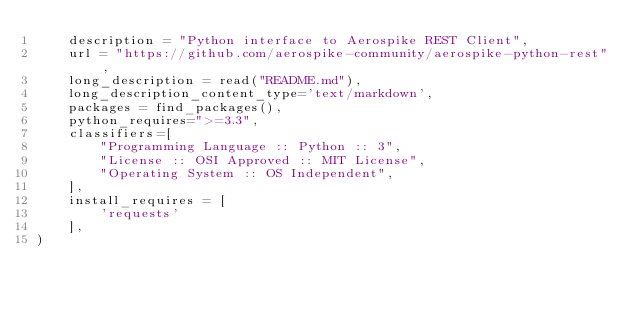Convert code to text. <code><loc_0><loc_0><loc_500><loc_500><_Python_>    description = "Python interface to Aerospike REST Client",
    url = "https://github.com/aerospike-community/aerospike-python-rest",
    long_description = read("README.md"),
    long_description_content_type='text/markdown',
    packages = find_packages(),
    python_requires=">=3.3",
    classifiers=[
        "Programming Language :: Python :: 3",
        "License :: OSI Approved :: MIT License",
        "Operating System :: OS Independent",
    ],
    install_requires = [
        'requests'
    ],
)
</code> 